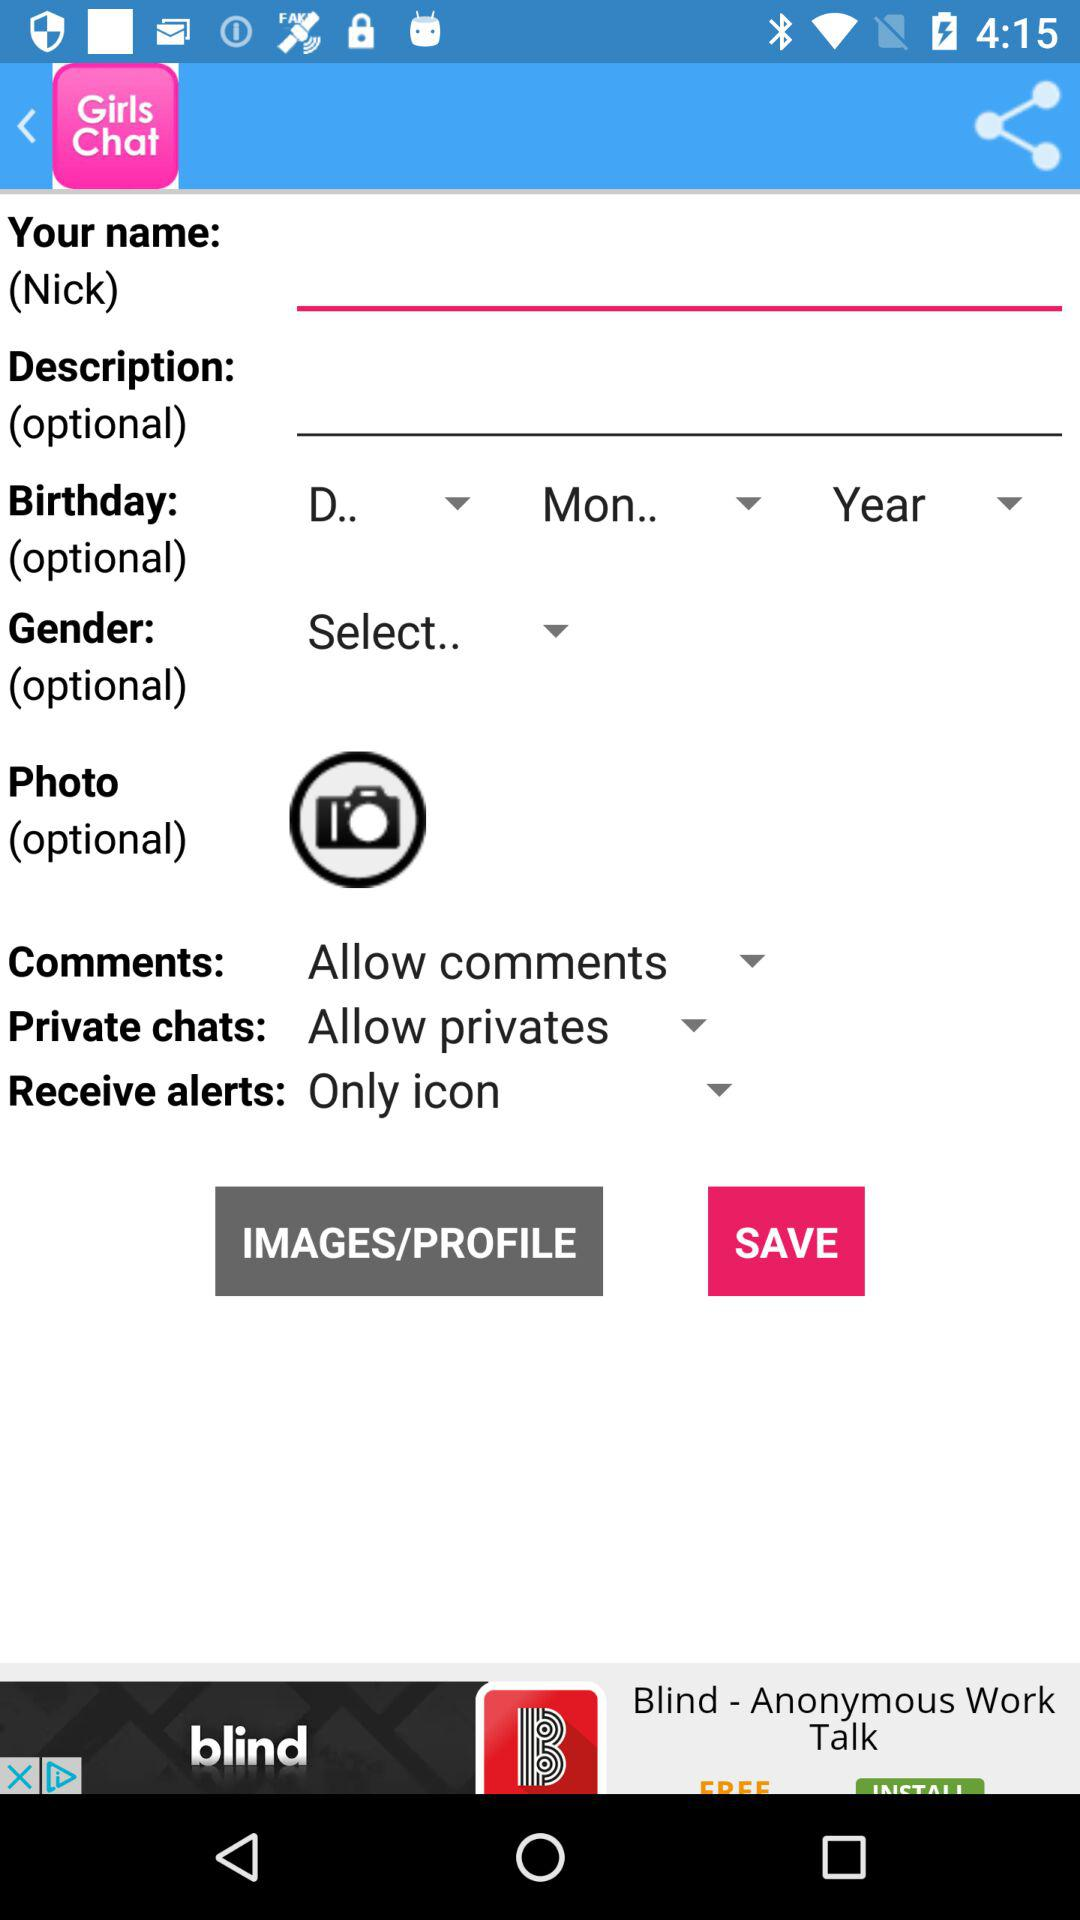What is the description?
When the provided information is insufficient, respond with <no answer>. <no answer> 